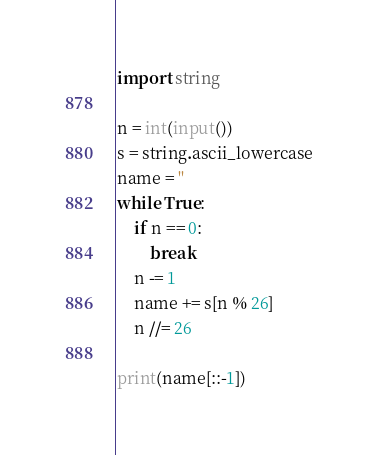Convert code to text. <code><loc_0><loc_0><loc_500><loc_500><_Python_>import string

n = int(input())
s = string.ascii_lowercase
name = ''
while True:
    if n == 0:
        break
    n -= 1
    name += s[n % 26]
    n //= 26

print(name[::-1])
</code> 